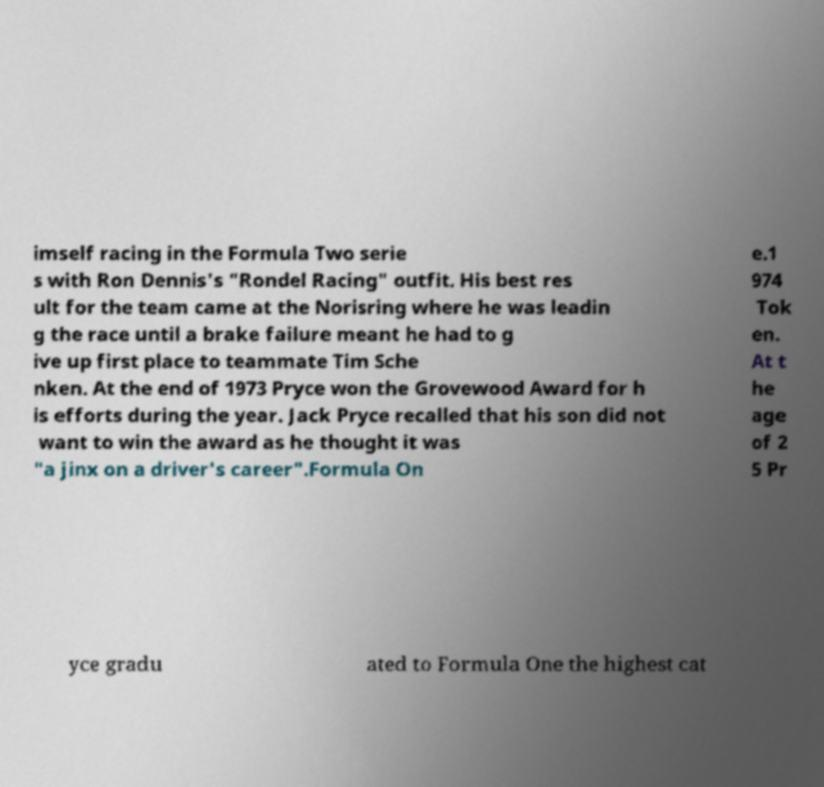I need the written content from this picture converted into text. Can you do that? imself racing in the Formula Two serie s with Ron Dennis's "Rondel Racing" outfit. His best res ult for the team came at the Norisring where he was leadin g the race until a brake failure meant he had to g ive up first place to teammate Tim Sche nken. At the end of 1973 Pryce won the Grovewood Award for h is efforts during the year. Jack Pryce recalled that his son did not want to win the award as he thought it was "a jinx on a driver's career".Formula On e.1 974 Tok en. At t he age of 2 5 Pr yce gradu ated to Formula One the highest cat 